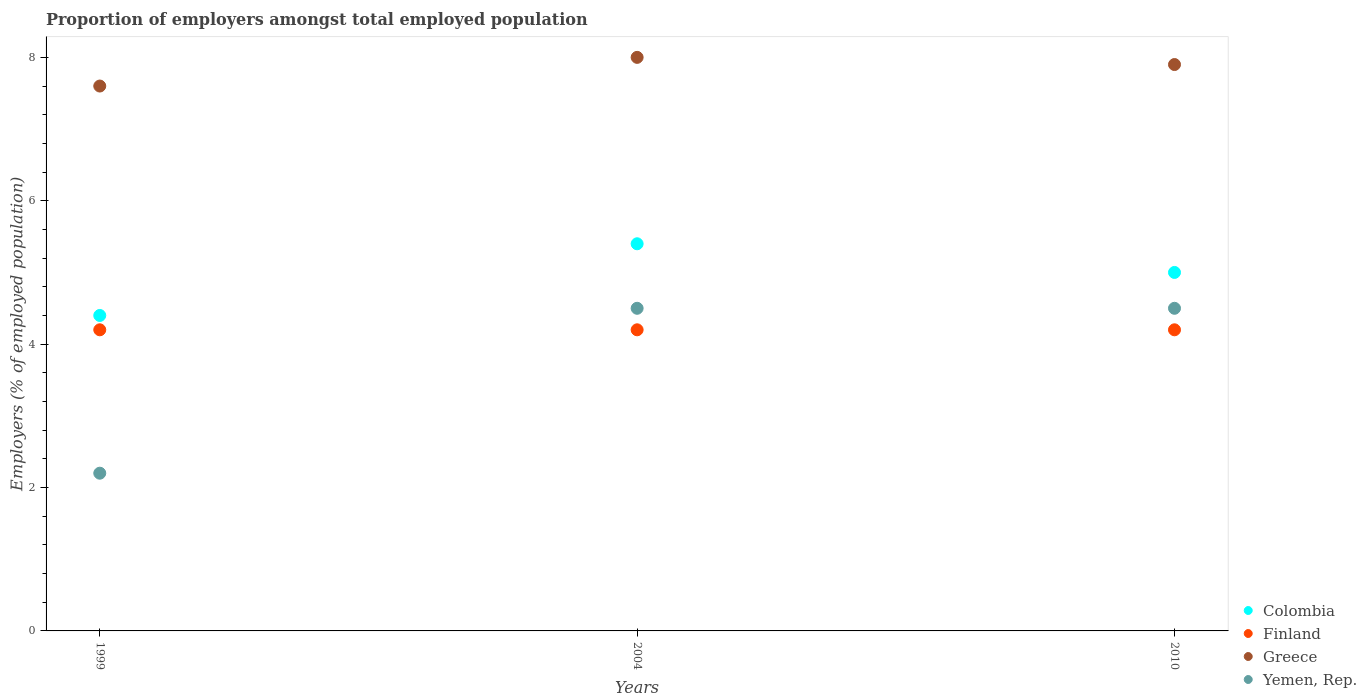Is the number of dotlines equal to the number of legend labels?
Keep it short and to the point. Yes. What is the proportion of employers in Finland in 2004?
Ensure brevity in your answer.  4.2. Across all years, what is the minimum proportion of employers in Greece?
Keep it short and to the point. 7.6. In which year was the proportion of employers in Yemen, Rep. maximum?
Offer a very short reply. 2004. In which year was the proportion of employers in Greece minimum?
Your response must be concise. 1999. What is the total proportion of employers in Yemen, Rep. in the graph?
Provide a short and direct response. 11.2. What is the difference between the proportion of employers in Greece in 1999 and that in 2010?
Your answer should be very brief. -0.3. What is the difference between the proportion of employers in Colombia in 1999 and the proportion of employers in Finland in 2010?
Your answer should be compact. 0.2. What is the average proportion of employers in Yemen, Rep. per year?
Provide a succinct answer. 3.73. In the year 2004, what is the difference between the proportion of employers in Finland and proportion of employers in Yemen, Rep.?
Your response must be concise. -0.3. In how many years, is the proportion of employers in Colombia greater than 6.8 %?
Provide a short and direct response. 0. What is the ratio of the proportion of employers in Yemen, Rep. in 2004 to that in 2010?
Ensure brevity in your answer.  1. Is the difference between the proportion of employers in Finland in 1999 and 2010 greater than the difference between the proportion of employers in Yemen, Rep. in 1999 and 2010?
Your answer should be very brief. Yes. What is the difference between the highest and the second highest proportion of employers in Finland?
Offer a terse response. 0. What is the difference between the highest and the lowest proportion of employers in Greece?
Provide a short and direct response. 0.4. Is it the case that in every year, the sum of the proportion of employers in Greece and proportion of employers in Colombia  is greater than the proportion of employers in Finland?
Provide a succinct answer. Yes. Does the proportion of employers in Yemen, Rep. monotonically increase over the years?
Offer a terse response. No. Is the proportion of employers in Colombia strictly greater than the proportion of employers in Yemen, Rep. over the years?
Keep it short and to the point. Yes. Is the proportion of employers in Finland strictly less than the proportion of employers in Greece over the years?
Make the answer very short. Yes. How many years are there in the graph?
Your answer should be compact. 3. What is the difference between two consecutive major ticks on the Y-axis?
Ensure brevity in your answer.  2. Are the values on the major ticks of Y-axis written in scientific E-notation?
Offer a terse response. No. Where does the legend appear in the graph?
Keep it short and to the point. Bottom right. How many legend labels are there?
Your answer should be compact. 4. What is the title of the graph?
Give a very brief answer. Proportion of employers amongst total employed population. Does "Ecuador" appear as one of the legend labels in the graph?
Offer a very short reply. No. What is the label or title of the Y-axis?
Make the answer very short. Employers (% of employed population). What is the Employers (% of employed population) of Colombia in 1999?
Your answer should be compact. 4.4. What is the Employers (% of employed population) of Finland in 1999?
Your response must be concise. 4.2. What is the Employers (% of employed population) of Greece in 1999?
Your answer should be compact. 7.6. What is the Employers (% of employed population) of Yemen, Rep. in 1999?
Keep it short and to the point. 2.2. What is the Employers (% of employed population) of Colombia in 2004?
Your response must be concise. 5.4. What is the Employers (% of employed population) of Finland in 2004?
Your response must be concise. 4.2. What is the Employers (% of employed population) in Colombia in 2010?
Give a very brief answer. 5. What is the Employers (% of employed population) in Finland in 2010?
Your answer should be very brief. 4.2. What is the Employers (% of employed population) in Greece in 2010?
Give a very brief answer. 7.9. Across all years, what is the maximum Employers (% of employed population) in Colombia?
Offer a terse response. 5.4. Across all years, what is the maximum Employers (% of employed population) of Finland?
Ensure brevity in your answer.  4.2. Across all years, what is the maximum Employers (% of employed population) of Yemen, Rep.?
Provide a succinct answer. 4.5. Across all years, what is the minimum Employers (% of employed population) of Colombia?
Your response must be concise. 4.4. Across all years, what is the minimum Employers (% of employed population) in Finland?
Ensure brevity in your answer.  4.2. Across all years, what is the minimum Employers (% of employed population) in Greece?
Your response must be concise. 7.6. Across all years, what is the minimum Employers (% of employed population) of Yemen, Rep.?
Your response must be concise. 2.2. What is the total Employers (% of employed population) of Colombia in the graph?
Your response must be concise. 14.8. What is the total Employers (% of employed population) of Finland in the graph?
Ensure brevity in your answer.  12.6. What is the total Employers (% of employed population) of Yemen, Rep. in the graph?
Your answer should be compact. 11.2. What is the difference between the Employers (% of employed population) of Colombia in 1999 and that in 2004?
Ensure brevity in your answer.  -1. What is the difference between the Employers (% of employed population) of Finland in 1999 and that in 2004?
Make the answer very short. 0. What is the difference between the Employers (% of employed population) of Greece in 1999 and that in 2004?
Ensure brevity in your answer.  -0.4. What is the difference between the Employers (% of employed population) in Yemen, Rep. in 1999 and that in 2004?
Give a very brief answer. -2.3. What is the difference between the Employers (% of employed population) of Colombia in 1999 and that in 2010?
Provide a short and direct response. -0.6. What is the difference between the Employers (% of employed population) in Finland in 1999 and that in 2010?
Your answer should be very brief. 0. What is the difference between the Employers (% of employed population) of Greece in 1999 and that in 2010?
Provide a succinct answer. -0.3. What is the difference between the Employers (% of employed population) in Yemen, Rep. in 1999 and that in 2010?
Make the answer very short. -2.3. What is the difference between the Employers (% of employed population) in Finland in 2004 and that in 2010?
Offer a very short reply. 0. What is the difference between the Employers (% of employed population) in Greece in 2004 and that in 2010?
Your answer should be compact. 0.1. What is the difference between the Employers (% of employed population) in Colombia in 1999 and the Employers (% of employed population) in Finland in 2010?
Offer a very short reply. 0.2. What is the difference between the Employers (% of employed population) in Colombia in 1999 and the Employers (% of employed population) in Greece in 2010?
Offer a very short reply. -3.5. What is the difference between the Employers (% of employed population) in Colombia in 1999 and the Employers (% of employed population) in Yemen, Rep. in 2010?
Provide a succinct answer. -0.1. What is the difference between the Employers (% of employed population) in Finland in 1999 and the Employers (% of employed population) in Yemen, Rep. in 2010?
Offer a terse response. -0.3. What is the difference between the Employers (% of employed population) of Greece in 1999 and the Employers (% of employed population) of Yemen, Rep. in 2010?
Provide a short and direct response. 3.1. What is the difference between the Employers (% of employed population) in Colombia in 2004 and the Employers (% of employed population) in Finland in 2010?
Ensure brevity in your answer.  1.2. What is the difference between the Employers (% of employed population) of Colombia in 2004 and the Employers (% of employed population) of Yemen, Rep. in 2010?
Offer a very short reply. 0.9. What is the average Employers (% of employed population) of Colombia per year?
Your response must be concise. 4.93. What is the average Employers (% of employed population) in Finland per year?
Offer a very short reply. 4.2. What is the average Employers (% of employed population) in Greece per year?
Provide a succinct answer. 7.83. What is the average Employers (% of employed population) of Yemen, Rep. per year?
Make the answer very short. 3.73. In the year 1999, what is the difference between the Employers (% of employed population) in Colombia and Employers (% of employed population) in Greece?
Offer a very short reply. -3.2. In the year 1999, what is the difference between the Employers (% of employed population) of Colombia and Employers (% of employed population) of Yemen, Rep.?
Your response must be concise. 2.2. In the year 1999, what is the difference between the Employers (% of employed population) of Finland and Employers (% of employed population) of Greece?
Provide a succinct answer. -3.4. In the year 1999, what is the difference between the Employers (% of employed population) in Finland and Employers (% of employed population) in Yemen, Rep.?
Your response must be concise. 2. In the year 2004, what is the difference between the Employers (% of employed population) in Colombia and Employers (% of employed population) in Finland?
Give a very brief answer. 1.2. In the year 2004, what is the difference between the Employers (% of employed population) in Colombia and Employers (% of employed population) in Greece?
Your answer should be very brief. -2.6. In the year 2010, what is the difference between the Employers (% of employed population) in Colombia and Employers (% of employed population) in Finland?
Offer a terse response. 0.8. In the year 2010, what is the difference between the Employers (% of employed population) of Colombia and Employers (% of employed population) of Yemen, Rep.?
Your response must be concise. 0.5. In the year 2010, what is the difference between the Employers (% of employed population) of Finland and Employers (% of employed population) of Greece?
Provide a succinct answer. -3.7. In the year 2010, what is the difference between the Employers (% of employed population) in Greece and Employers (% of employed population) in Yemen, Rep.?
Give a very brief answer. 3.4. What is the ratio of the Employers (% of employed population) in Colombia in 1999 to that in 2004?
Keep it short and to the point. 0.81. What is the ratio of the Employers (% of employed population) of Finland in 1999 to that in 2004?
Ensure brevity in your answer.  1. What is the ratio of the Employers (% of employed population) in Greece in 1999 to that in 2004?
Give a very brief answer. 0.95. What is the ratio of the Employers (% of employed population) of Yemen, Rep. in 1999 to that in 2004?
Provide a succinct answer. 0.49. What is the ratio of the Employers (% of employed population) in Colombia in 1999 to that in 2010?
Give a very brief answer. 0.88. What is the ratio of the Employers (% of employed population) in Greece in 1999 to that in 2010?
Give a very brief answer. 0.96. What is the ratio of the Employers (% of employed population) in Yemen, Rep. in 1999 to that in 2010?
Give a very brief answer. 0.49. What is the ratio of the Employers (% of employed population) in Finland in 2004 to that in 2010?
Offer a terse response. 1. What is the ratio of the Employers (% of employed population) in Greece in 2004 to that in 2010?
Offer a terse response. 1.01. What is the difference between the highest and the second highest Employers (% of employed population) in Yemen, Rep.?
Keep it short and to the point. 0. What is the difference between the highest and the lowest Employers (% of employed population) of Finland?
Your answer should be compact. 0. What is the difference between the highest and the lowest Employers (% of employed population) in Greece?
Offer a very short reply. 0.4. 